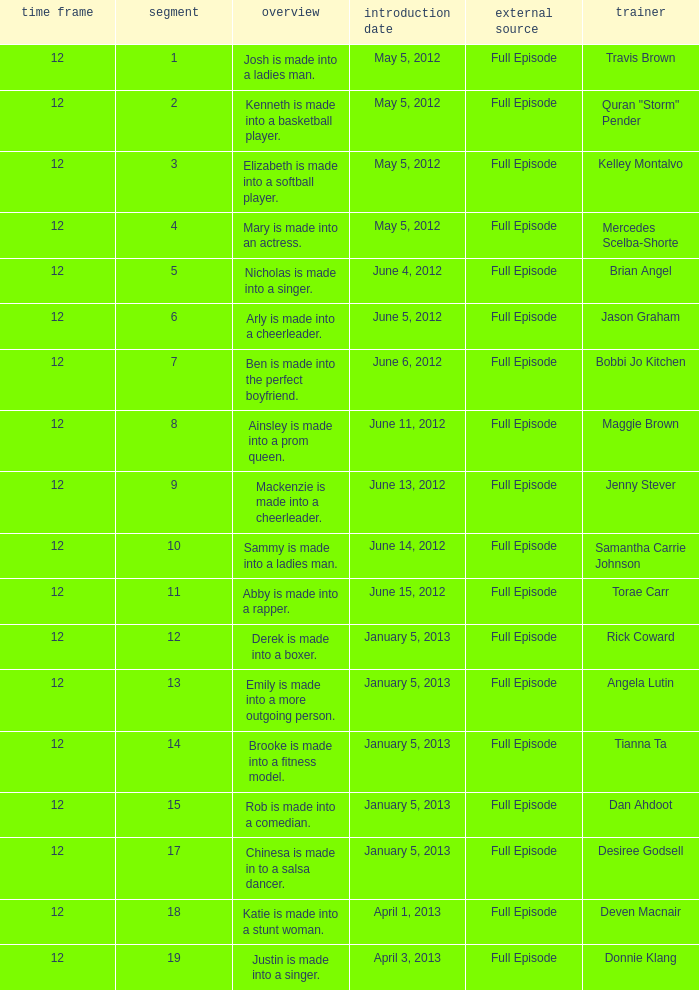Name the coach for  emily is made into a more outgoing person. Angela Lutin. 